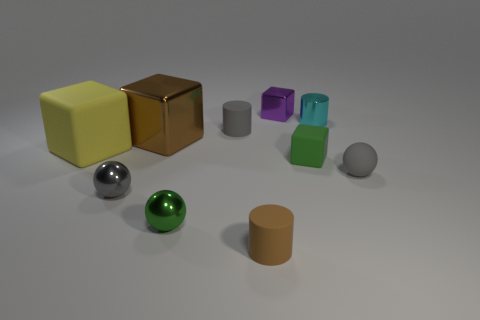The small metal object that is the same color as the matte ball is what shape?
Ensure brevity in your answer.  Sphere. Do the sphere that is in front of the gray metal sphere and the small cylinder that is in front of the tiny green sphere have the same material?
Provide a succinct answer. No. Is the number of cyan things to the left of the brown matte cylinder the same as the number of large brown blocks that are in front of the gray matte sphere?
Offer a very short reply. Yes. What is the color of the matte cube that is the same size as the gray rubber cylinder?
Provide a succinct answer. Green. Are there any tiny rubber things of the same color as the tiny matte ball?
Provide a short and direct response. Yes. What number of things are either green matte cubes that are right of the big metallic block or gray shiny cubes?
Provide a succinct answer. 1. What number of other things are the same size as the green matte block?
Give a very brief answer. 7. There is a tiny cylinder to the right of the shiny block behind the rubber cylinder behind the big matte cube; what is its material?
Your response must be concise. Metal. How many cubes are matte objects or gray metal things?
Give a very brief answer. 2. Are there any other things that are the same shape as the tiny purple object?
Provide a succinct answer. Yes. 